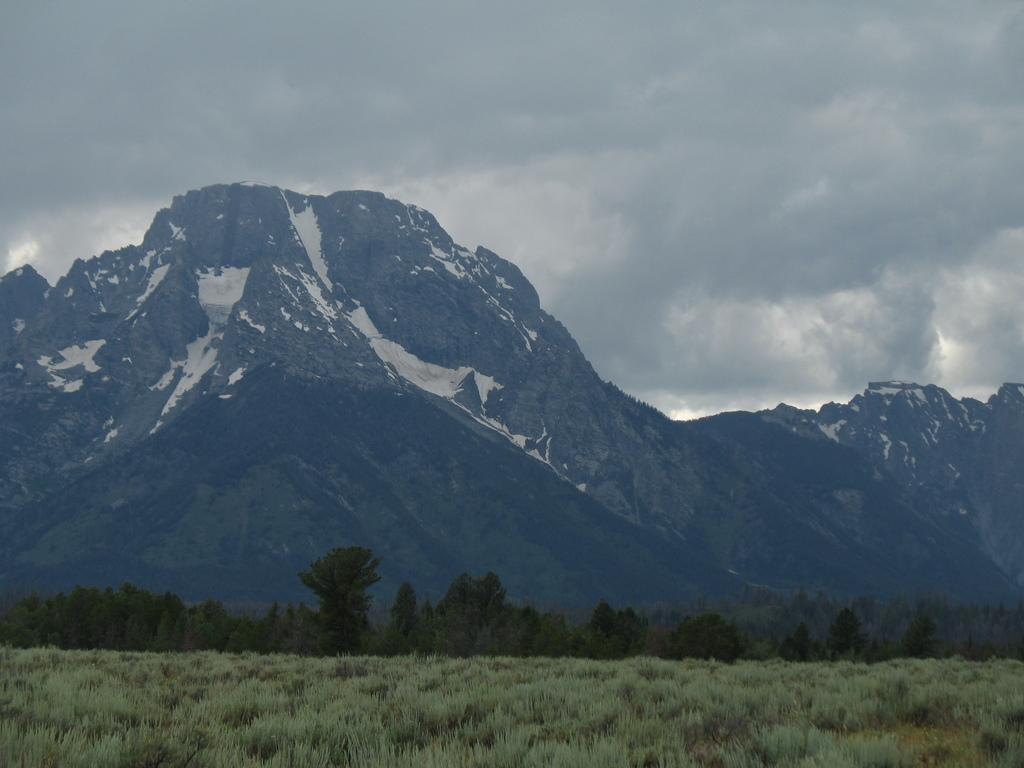What type of vegetation is present in the image? There is grass in the image. What other natural elements can be seen in the image? There are trees and snowy mountains in the image. What is visible in the background of the image? The sky is visible in the background of the image. What topics are being discussed by the trees in the image? There are no discussions taking place in the image, as trees are inanimate objects and cannot engage in discussions. 